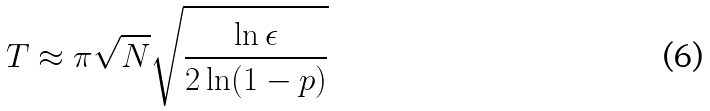<formula> <loc_0><loc_0><loc_500><loc_500>T \approx \pi \sqrt { N } \sqrt { \frac { \ln \epsilon } { 2 \ln ( 1 - p ) } }</formula> 